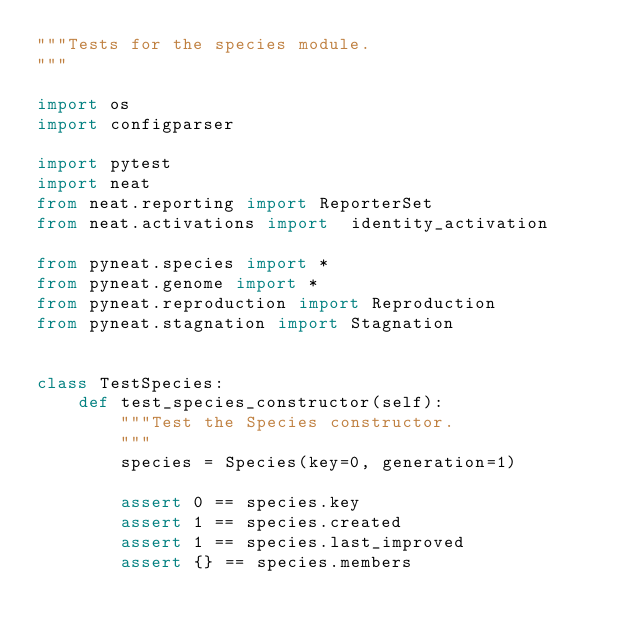<code> <loc_0><loc_0><loc_500><loc_500><_Python_>"""Tests for the species module.
"""

import os
import configparser

import pytest
import neat
from neat.reporting import ReporterSet
from neat.activations import  identity_activation

from pyneat.species import *
from pyneat.genome import *
from pyneat.reproduction import Reproduction
from pyneat.stagnation import Stagnation


class TestSpecies:
    def test_species_constructor(self):
        """Test the Species constructor.
        """
        species = Species(key=0, generation=1)

        assert 0 == species.key
        assert 1 == species.created
        assert 1 == species.last_improved
        assert {} == species.members</code> 